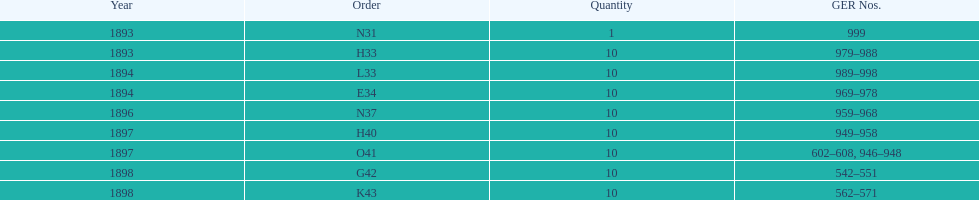Was the quantity higher in 1894 or 1893? 1894. 